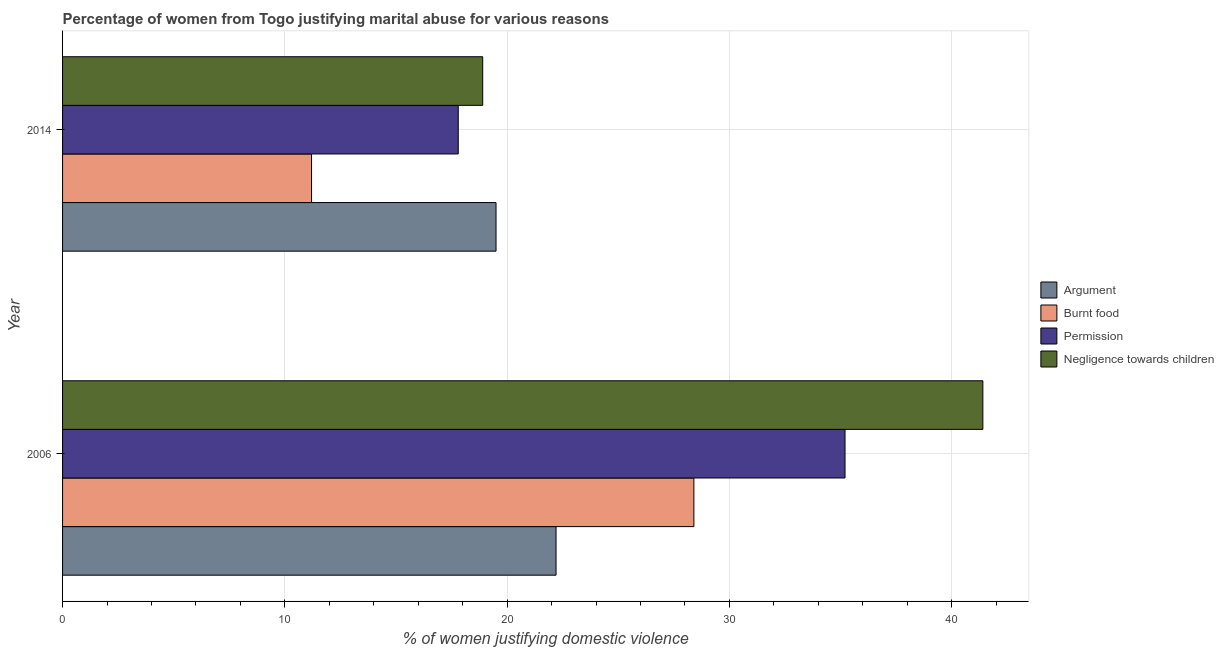How many different coloured bars are there?
Keep it short and to the point. 4. How many groups of bars are there?
Ensure brevity in your answer.  2. How many bars are there on the 2nd tick from the bottom?
Offer a very short reply. 4. What is the label of the 2nd group of bars from the top?
Give a very brief answer. 2006. In how many cases, is the number of bars for a given year not equal to the number of legend labels?
Make the answer very short. 0. What is the percentage of women justifying abuse in the case of an argument in 2014?
Provide a succinct answer. 19.5. Across all years, what is the maximum percentage of women justifying abuse for burning food?
Your answer should be very brief. 28.4. Across all years, what is the minimum percentage of women justifying abuse in the case of an argument?
Ensure brevity in your answer.  19.5. In which year was the percentage of women justifying abuse in the case of an argument minimum?
Your response must be concise. 2014. What is the total percentage of women justifying abuse in the case of an argument in the graph?
Make the answer very short. 41.7. What is the difference between the percentage of women justifying abuse for going without permission in 2014 and the percentage of women justifying abuse in the case of an argument in 2006?
Ensure brevity in your answer.  -4.4. What is the average percentage of women justifying abuse in the case of an argument per year?
Keep it short and to the point. 20.85. In the year 2006, what is the difference between the percentage of women justifying abuse for burning food and percentage of women justifying abuse in the case of an argument?
Provide a short and direct response. 6.2. In how many years, is the percentage of women justifying abuse in the case of an argument greater than 36 %?
Your answer should be very brief. 0. What is the ratio of the percentage of women justifying abuse in the case of an argument in 2006 to that in 2014?
Provide a succinct answer. 1.14. Is the percentage of women justifying abuse for showing negligence towards children in 2006 less than that in 2014?
Give a very brief answer. No. In how many years, is the percentage of women justifying abuse for going without permission greater than the average percentage of women justifying abuse for going without permission taken over all years?
Ensure brevity in your answer.  1. What does the 3rd bar from the top in 2006 represents?
Provide a succinct answer. Burnt food. What does the 1st bar from the bottom in 2006 represents?
Give a very brief answer. Argument. How many years are there in the graph?
Your answer should be very brief. 2. Does the graph contain any zero values?
Keep it short and to the point. No. How many legend labels are there?
Provide a succinct answer. 4. How are the legend labels stacked?
Offer a terse response. Vertical. What is the title of the graph?
Offer a very short reply. Percentage of women from Togo justifying marital abuse for various reasons. What is the label or title of the X-axis?
Your answer should be compact. % of women justifying domestic violence. What is the % of women justifying domestic violence of Argument in 2006?
Your answer should be compact. 22.2. What is the % of women justifying domestic violence in Burnt food in 2006?
Your response must be concise. 28.4. What is the % of women justifying domestic violence in Permission in 2006?
Make the answer very short. 35.2. What is the % of women justifying domestic violence in Negligence towards children in 2006?
Make the answer very short. 41.4. Across all years, what is the maximum % of women justifying domestic violence in Burnt food?
Offer a very short reply. 28.4. Across all years, what is the maximum % of women justifying domestic violence of Permission?
Offer a terse response. 35.2. Across all years, what is the maximum % of women justifying domestic violence in Negligence towards children?
Offer a very short reply. 41.4. What is the total % of women justifying domestic violence of Argument in the graph?
Provide a succinct answer. 41.7. What is the total % of women justifying domestic violence in Burnt food in the graph?
Give a very brief answer. 39.6. What is the total % of women justifying domestic violence of Negligence towards children in the graph?
Ensure brevity in your answer.  60.3. What is the difference between the % of women justifying domestic violence of Argument in 2006 and the % of women justifying domestic violence of Permission in 2014?
Make the answer very short. 4.4. What is the difference between the % of women justifying domestic violence in Burnt food in 2006 and the % of women justifying domestic violence in Permission in 2014?
Provide a succinct answer. 10.6. What is the difference between the % of women justifying domestic violence in Burnt food in 2006 and the % of women justifying domestic violence in Negligence towards children in 2014?
Your response must be concise. 9.5. What is the average % of women justifying domestic violence of Argument per year?
Make the answer very short. 20.85. What is the average % of women justifying domestic violence in Burnt food per year?
Keep it short and to the point. 19.8. What is the average % of women justifying domestic violence in Permission per year?
Your response must be concise. 26.5. What is the average % of women justifying domestic violence in Negligence towards children per year?
Your answer should be very brief. 30.15. In the year 2006, what is the difference between the % of women justifying domestic violence in Argument and % of women justifying domestic violence in Negligence towards children?
Your response must be concise. -19.2. In the year 2006, what is the difference between the % of women justifying domestic violence in Burnt food and % of women justifying domestic violence in Permission?
Ensure brevity in your answer.  -6.8. In the year 2006, what is the difference between the % of women justifying domestic violence of Burnt food and % of women justifying domestic violence of Negligence towards children?
Your answer should be compact. -13. In the year 2014, what is the difference between the % of women justifying domestic violence of Argument and % of women justifying domestic violence of Burnt food?
Ensure brevity in your answer.  8.3. In the year 2014, what is the difference between the % of women justifying domestic violence of Argument and % of women justifying domestic violence of Permission?
Your answer should be very brief. 1.7. In the year 2014, what is the difference between the % of women justifying domestic violence in Argument and % of women justifying domestic violence in Negligence towards children?
Provide a short and direct response. 0.6. In the year 2014, what is the difference between the % of women justifying domestic violence of Burnt food and % of women justifying domestic violence of Negligence towards children?
Give a very brief answer. -7.7. What is the ratio of the % of women justifying domestic violence of Argument in 2006 to that in 2014?
Offer a very short reply. 1.14. What is the ratio of the % of women justifying domestic violence in Burnt food in 2006 to that in 2014?
Offer a terse response. 2.54. What is the ratio of the % of women justifying domestic violence in Permission in 2006 to that in 2014?
Make the answer very short. 1.98. What is the ratio of the % of women justifying domestic violence of Negligence towards children in 2006 to that in 2014?
Your answer should be very brief. 2.19. What is the difference between the highest and the second highest % of women justifying domestic violence in Permission?
Your response must be concise. 17.4. What is the difference between the highest and the lowest % of women justifying domestic violence in Permission?
Make the answer very short. 17.4. What is the difference between the highest and the lowest % of women justifying domestic violence in Negligence towards children?
Provide a succinct answer. 22.5. 